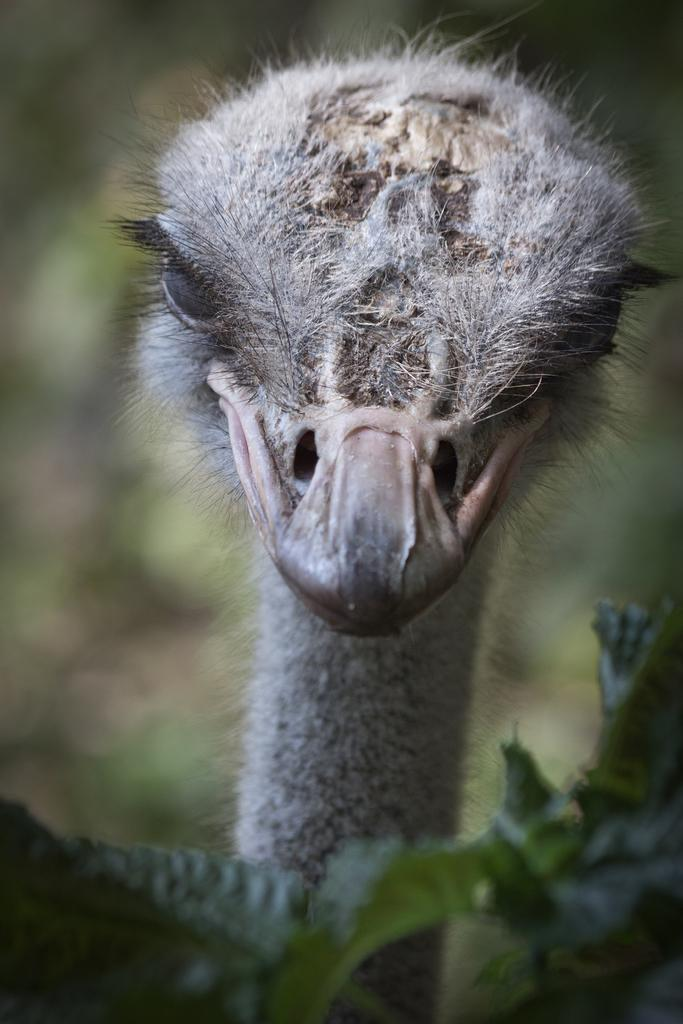What type of animal is present in the image? There is a bird in the image. Can you describe the bird's appearance? The bird resembles an ostrich. What is the bird doing in the image? The bird is staring. What type of kite is the bird holding in the image? There is no kite present in the image; it features a bird resembling an ostrich that is staring. 